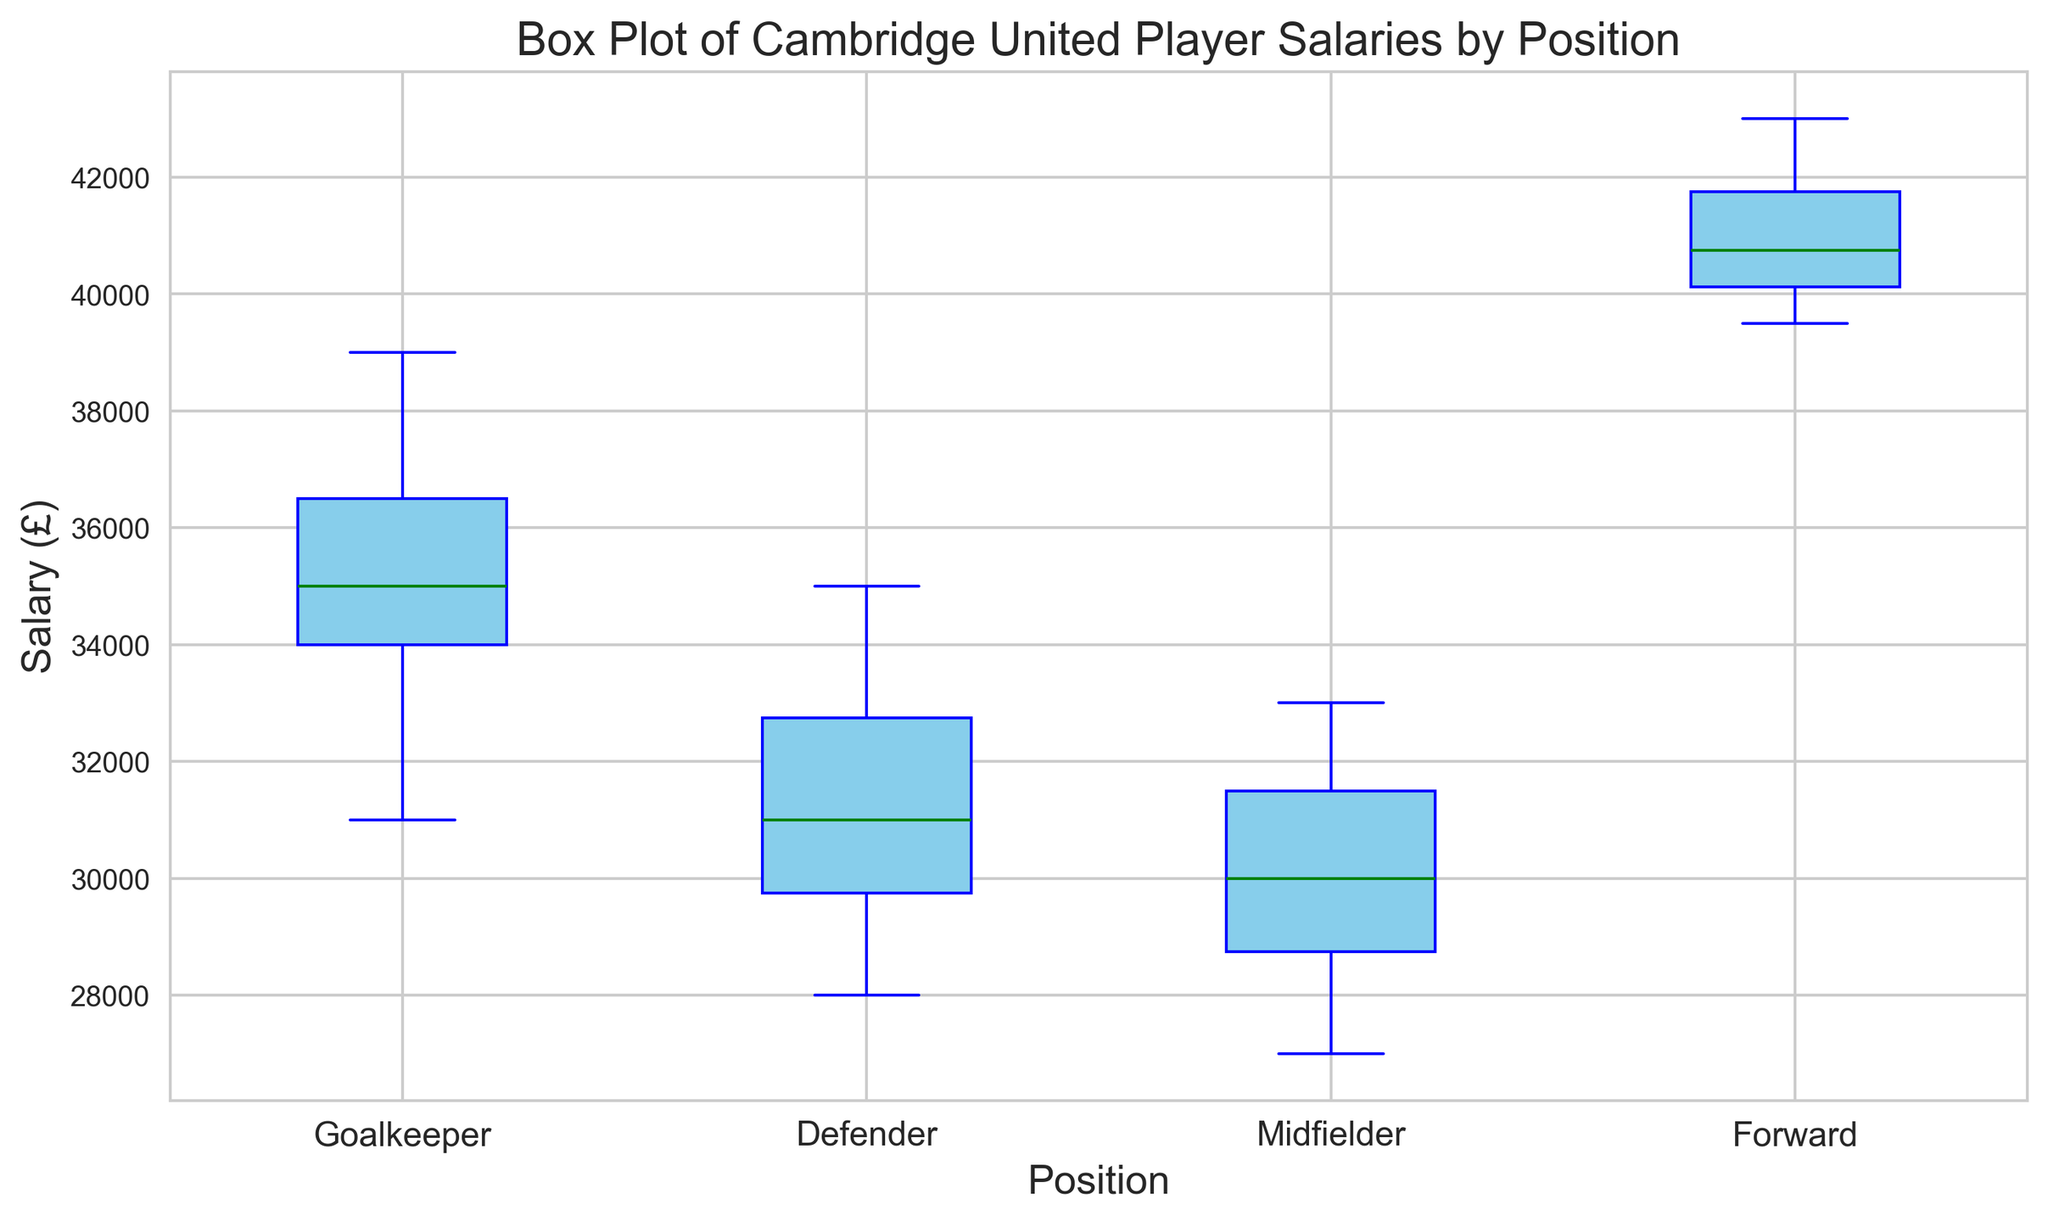What's the median salary for goalkeepers and how does it compare to midfielders? To find the median salary for goalkeepers, we note the salaries are 31000, 34000, 35000, 36500, and 39000. The median is the middle value, 35000. For midfielders, the salaries are 27000, 28500, 29000, 30000, 31000, 32000, and 33000, so the median is 30000. Comparing the two, goalkeepers have a higher median salary than midfielders.
Answer: Goalkeepers: 35000, Midfielders: 30000. Goalkeepers have a higher median salary Which position has the highest median salary? Compare the median salaries of all positions: Goalkeepers have a median of 35000, Defenders have 31000, Midfielders have 30000, and Forwards have 40500. Forwards have the highest median salary.
Answer: Forwards What is the interquartile range (IQR) for defenders' salaries? The defenders' salaries are sorted as 28000, 29500, 30000, 31000, 32000, 33500, and 35000. The first quartile (Q1) is 29500, and the third quartile (Q3) is 33500, so the IQR is Q3 - Q1 = 33500 - 29500.
Answer: 4000 Which position has the widest range in salaries? The range is the difference between the highest and lowest salaries for each position. For Goalkeepers: (39000 - 31000) = 8000, Defenders: (35000 - 28000) = 7000, Midfielders: (33000 - 27000) = 6000, Forwards: (43000 - 39500) = 3500. Goalkeepers have the widest range.
Answer: Goalkeepers Are there any outliers in the salary data? If so, for which positions? Outliers are data points that fall below Q1 - 1.5*IQR or above Q3 + 1.5*IQR. Calculate for each position: Goalkeepers (IQR = 5800), Defenders (IQR = 4000), Midfielders (IQR = 5000), Forwards (IQR = 3500). No values are identified as outliers visually by the absence of red markers.
Answer: No How does the median salary of midfielders compare to the 75th percentile salary of defenders? The median salary of midfielders is 30000. The 75th percentile (Q3) salary for defenders is 33500. The 75th percentile for defenders is higher than the median for midfielders.
Answer: Defenders' Q3 is higher Which position has the least variability in salaries? Variability can be judged by the height of the boxes in the box plot. Narrower boxes indicate less variability. Visually, the forwards' position has the narrowest box.
Answer: Forwards What is the difference between the maximum salary of forwards and the minimum salary of goalkeepers? The maximum salary of forwards is 43000 and the minimum salary of goalkeepers is 31000. The difference is 43000 - 31000.
Answer: 12000 